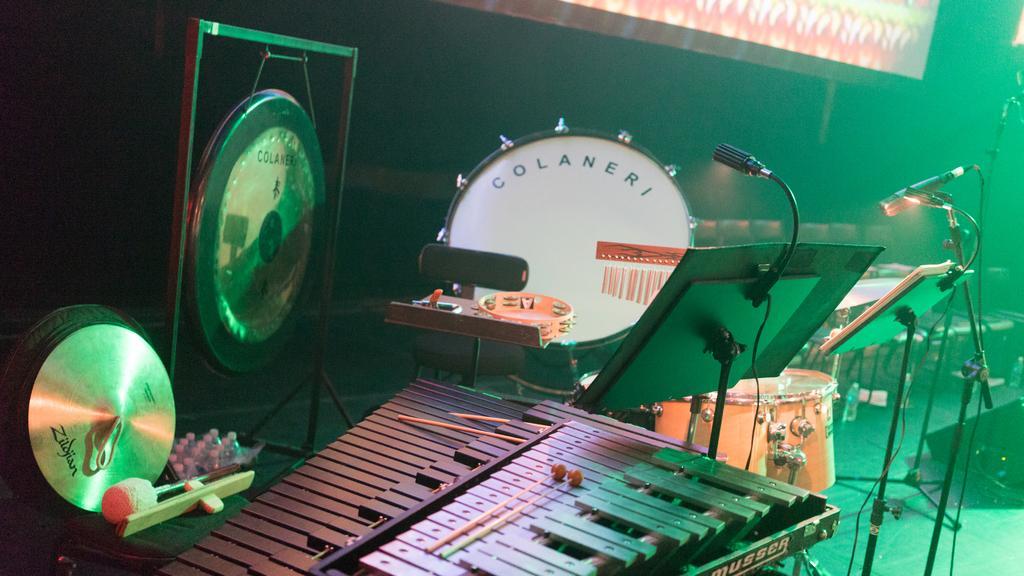How would you summarize this image in a sentence or two? In this image, I can see a vibraphone, drums, tambourine and some other musical instruments. I can see the music stands. These are the mics attached to the mike stands. 